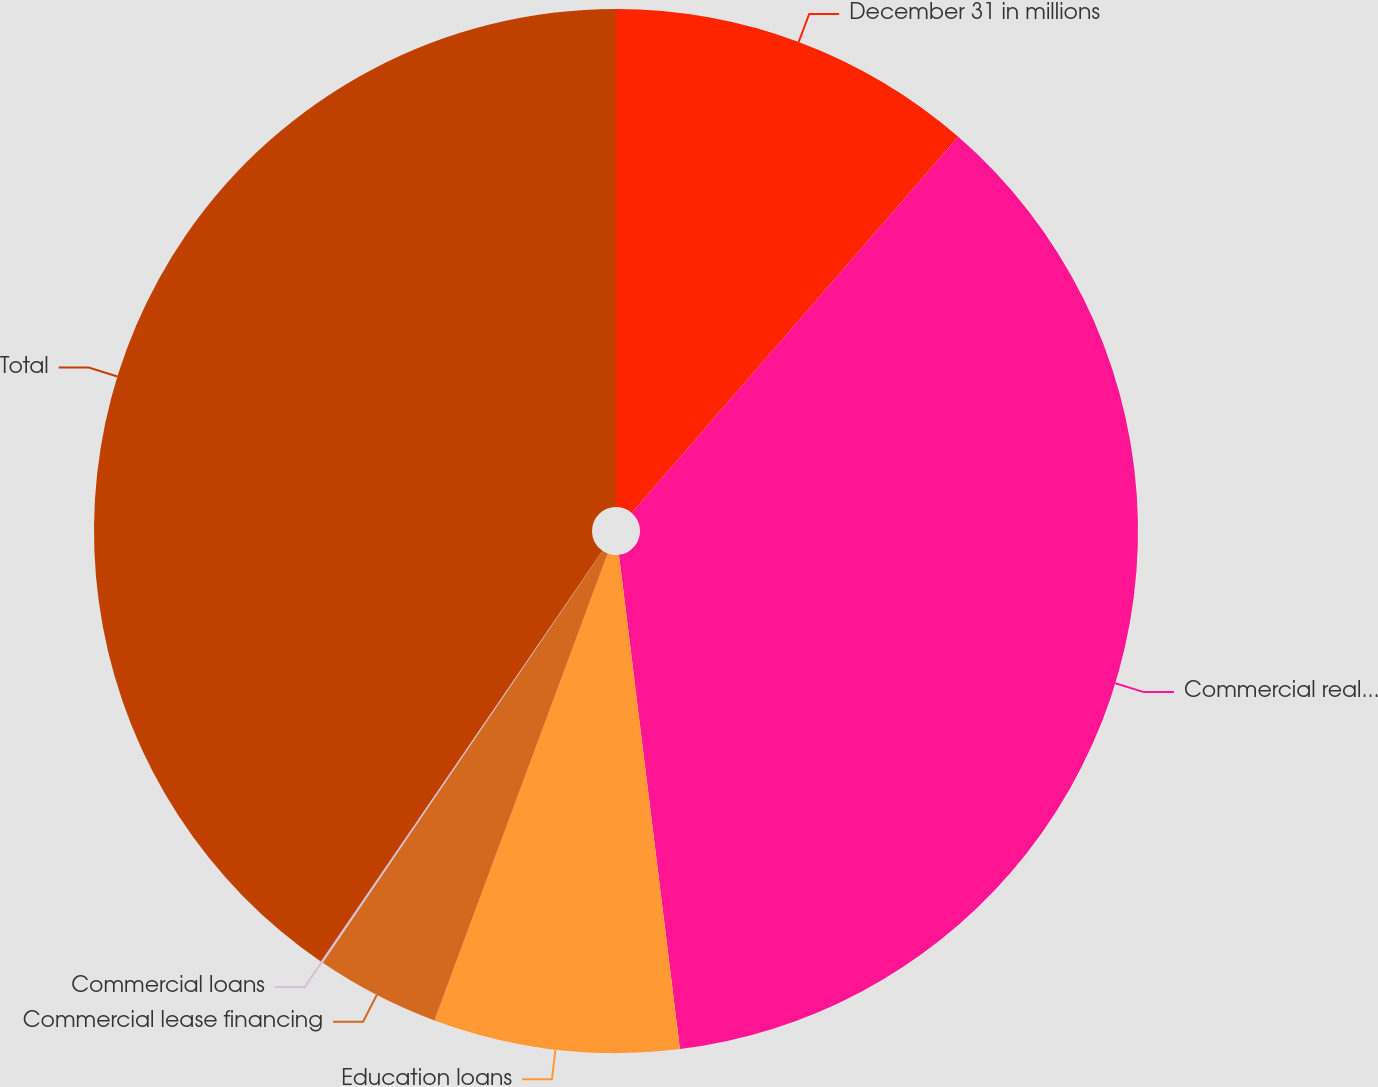Convert chart to OTSL. <chart><loc_0><loc_0><loc_500><loc_500><pie_chart><fcel>December 31 in millions<fcel>Commercial real estate loans<fcel>Education loans<fcel>Commercial lease financing<fcel>Commercial loans<fcel>Total<nl><fcel>11.38%<fcel>36.66%<fcel>7.61%<fcel>3.84%<fcel>0.07%<fcel>40.43%<nl></chart> 